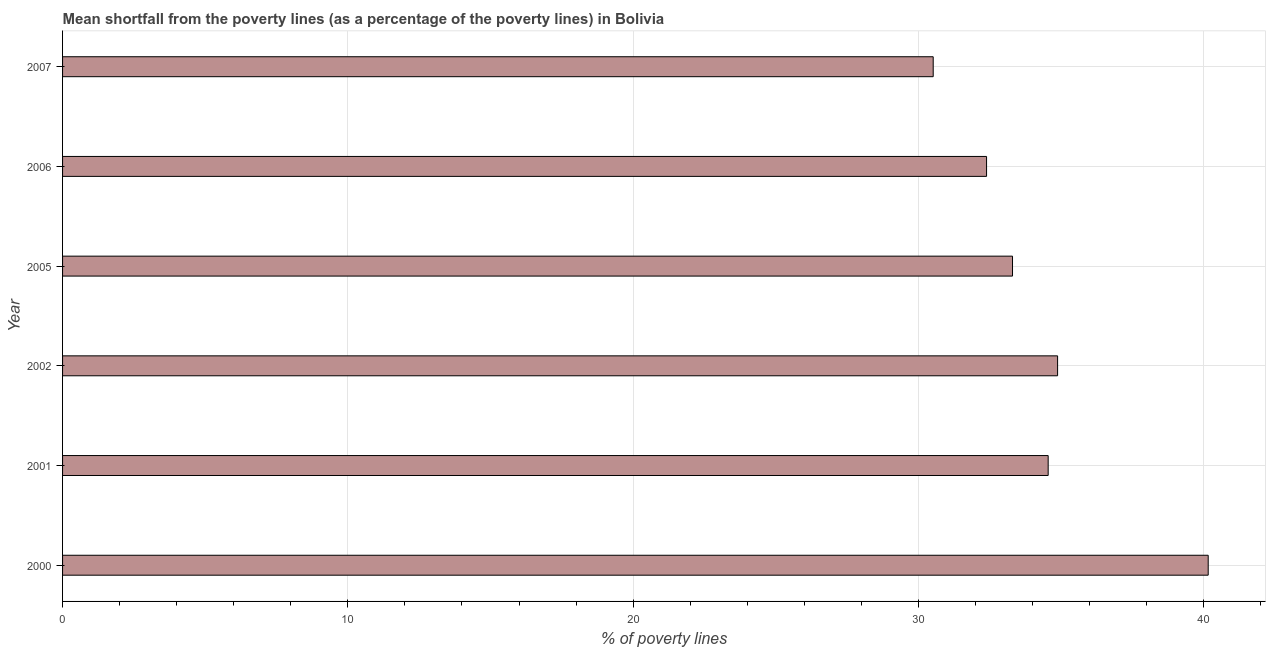Does the graph contain any zero values?
Your answer should be compact. No. Does the graph contain grids?
Give a very brief answer. Yes. What is the title of the graph?
Give a very brief answer. Mean shortfall from the poverty lines (as a percentage of the poverty lines) in Bolivia. What is the label or title of the X-axis?
Your answer should be very brief. % of poverty lines. What is the poverty gap at national poverty lines in 2006?
Make the answer very short. 32.39. Across all years, what is the maximum poverty gap at national poverty lines?
Your response must be concise. 40.16. Across all years, what is the minimum poverty gap at national poverty lines?
Your response must be concise. 30.52. In which year was the poverty gap at national poverty lines maximum?
Provide a short and direct response. 2000. In which year was the poverty gap at national poverty lines minimum?
Your answer should be compact. 2007. What is the sum of the poverty gap at national poverty lines?
Your answer should be very brief. 205.8. What is the difference between the poverty gap at national poverty lines in 2006 and 2007?
Make the answer very short. 1.87. What is the average poverty gap at national poverty lines per year?
Offer a terse response. 34.3. What is the median poverty gap at national poverty lines?
Make the answer very short. 33.92. Do a majority of the years between 2000 and 2006 (inclusive) have poverty gap at national poverty lines greater than 38 %?
Your response must be concise. No. What is the ratio of the poverty gap at national poverty lines in 2001 to that in 2005?
Provide a short and direct response. 1.04. Is the poverty gap at national poverty lines in 2006 less than that in 2007?
Your answer should be compact. No. What is the difference between the highest and the second highest poverty gap at national poverty lines?
Keep it short and to the point. 5.28. Is the sum of the poverty gap at national poverty lines in 2006 and 2007 greater than the maximum poverty gap at national poverty lines across all years?
Keep it short and to the point. Yes. What is the difference between the highest and the lowest poverty gap at national poverty lines?
Offer a terse response. 9.64. In how many years, is the poverty gap at national poverty lines greater than the average poverty gap at national poverty lines taken over all years?
Your answer should be very brief. 3. How many bars are there?
Provide a short and direct response. 6. How many years are there in the graph?
Ensure brevity in your answer.  6. What is the difference between two consecutive major ticks on the X-axis?
Offer a terse response. 10. What is the % of poverty lines in 2000?
Give a very brief answer. 40.16. What is the % of poverty lines of 2001?
Give a very brief answer. 34.55. What is the % of poverty lines of 2002?
Ensure brevity in your answer.  34.88. What is the % of poverty lines of 2005?
Make the answer very short. 33.3. What is the % of poverty lines in 2006?
Your answer should be very brief. 32.39. What is the % of poverty lines in 2007?
Your answer should be compact. 30.52. What is the difference between the % of poverty lines in 2000 and 2001?
Ensure brevity in your answer.  5.61. What is the difference between the % of poverty lines in 2000 and 2002?
Ensure brevity in your answer.  5.28. What is the difference between the % of poverty lines in 2000 and 2005?
Your answer should be compact. 6.86. What is the difference between the % of poverty lines in 2000 and 2006?
Your answer should be compact. 7.77. What is the difference between the % of poverty lines in 2000 and 2007?
Your response must be concise. 9.64. What is the difference between the % of poverty lines in 2001 and 2002?
Your answer should be very brief. -0.33. What is the difference between the % of poverty lines in 2001 and 2005?
Give a very brief answer. 1.25. What is the difference between the % of poverty lines in 2001 and 2006?
Offer a very short reply. 2.16. What is the difference between the % of poverty lines in 2001 and 2007?
Your answer should be compact. 4.03. What is the difference between the % of poverty lines in 2002 and 2005?
Offer a terse response. 1.58. What is the difference between the % of poverty lines in 2002 and 2006?
Provide a succinct answer. 2.49. What is the difference between the % of poverty lines in 2002 and 2007?
Offer a very short reply. 4.36. What is the difference between the % of poverty lines in 2005 and 2006?
Provide a succinct answer. 0.91. What is the difference between the % of poverty lines in 2005 and 2007?
Your answer should be compact. 2.78. What is the difference between the % of poverty lines in 2006 and 2007?
Keep it short and to the point. 1.87. What is the ratio of the % of poverty lines in 2000 to that in 2001?
Offer a terse response. 1.16. What is the ratio of the % of poverty lines in 2000 to that in 2002?
Your answer should be very brief. 1.15. What is the ratio of the % of poverty lines in 2000 to that in 2005?
Make the answer very short. 1.21. What is the ratio of the % of poverty lines in 2000 to that in 2006?
Ensure brevity in your answer.  1.24. What is the ratio of the % of poverty lines in 2000 to that in 2007?
Your answer should be very brief. 1.32. What is the ratio of the % of poverty lines in 2001 to that in 2002?
Your response must be concise. 0.99. What is the ratio of the % of poverty lines in 2001 to that in 2005?
Your response must be concise. 1.04. What is the ratio of the % of poverty lines in 2001 to that in 2006?
Offer a very short reply. 1.07. What is the ratio of the % of poverty lines in 2001 to that in 2007?
Ensure brevity in your answer.  1.13. What is the ratio of the % of poverty lines in 2002 to that in 2005?
Offer a very short reply. 1.05. What is the ratio of the % of poverty lines in 2002 to that in 2006?
Ensure brevity in your answer.  1.08. What is the ratio of the % of poverty lines in 2002 to that in 2007?
Offer a very short reply. 1.14. What is the ratio of the % of poverty lines in 2005 to that in 2006?
Ensure brevity in your answer.  1.03. What is the ratio of the % of poverty lines in 2005 to that in 2007?
Give a very brief answer. 1.09. What is the ratio of the % of poverty lines in 2006 to that in 2007?
Offer a very short reply. 1.06. 